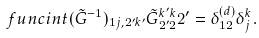<formula> <loc_0><loc_0><loc_500><loc_500>\ f u n c i n t { ( \tilde { G } ^ { - 1 } ) _ { 1 j , 2 ^ { \prime } k ^ { \prime } } \tilde { G } _ { 2 ^ { \prime } 2 } ^ { k ^ { \prime } k } } { 2 ^ { \prime } } = \delta _ { 1 2 } ^ { ( d ) } \delta _ { j } ^ { k } .</formula> 